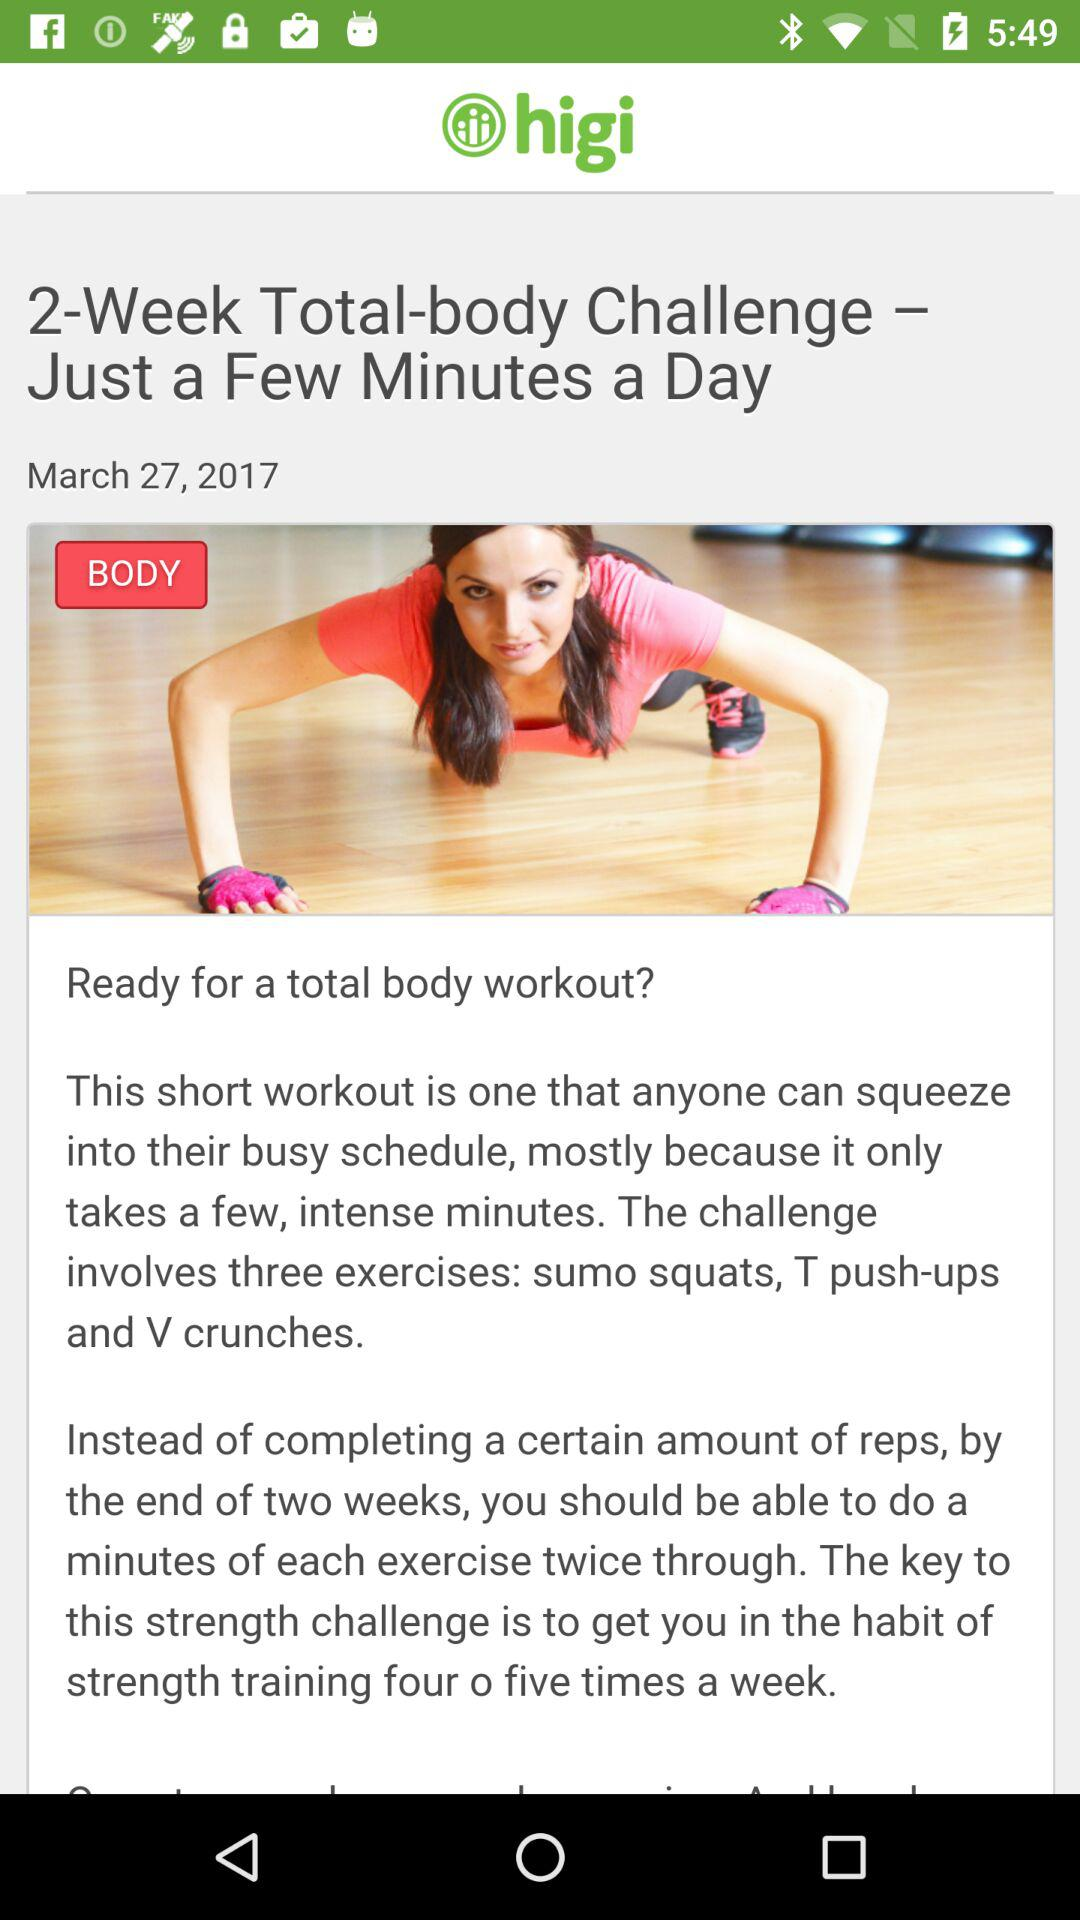How many weeks is the body challenge? The body challenge is for 2 weeks. 